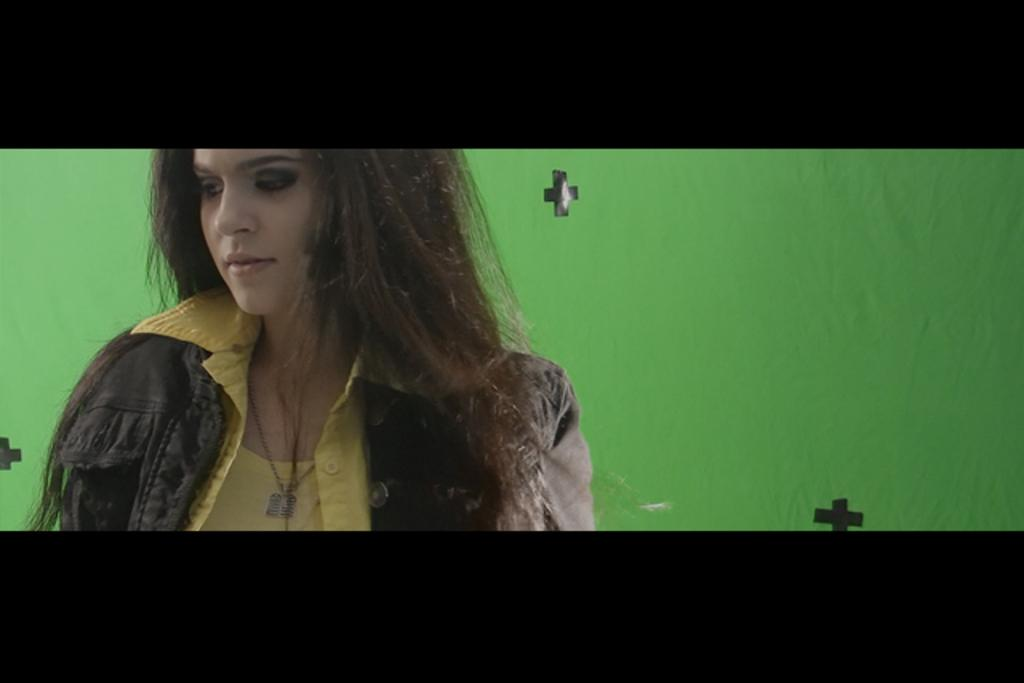Who or what is present in the image? There is a person in the image. What is the person wearing on their upper body? The person is wearing a gray jacket and a yellow shirt. What color is the background of the image? The background of the image is green. What type of carpenter tools can be seen in the image? There are no carpenter tools present in the image. What is the person's position in the image? The person's position in the image cannot be determined from the provided facts. 